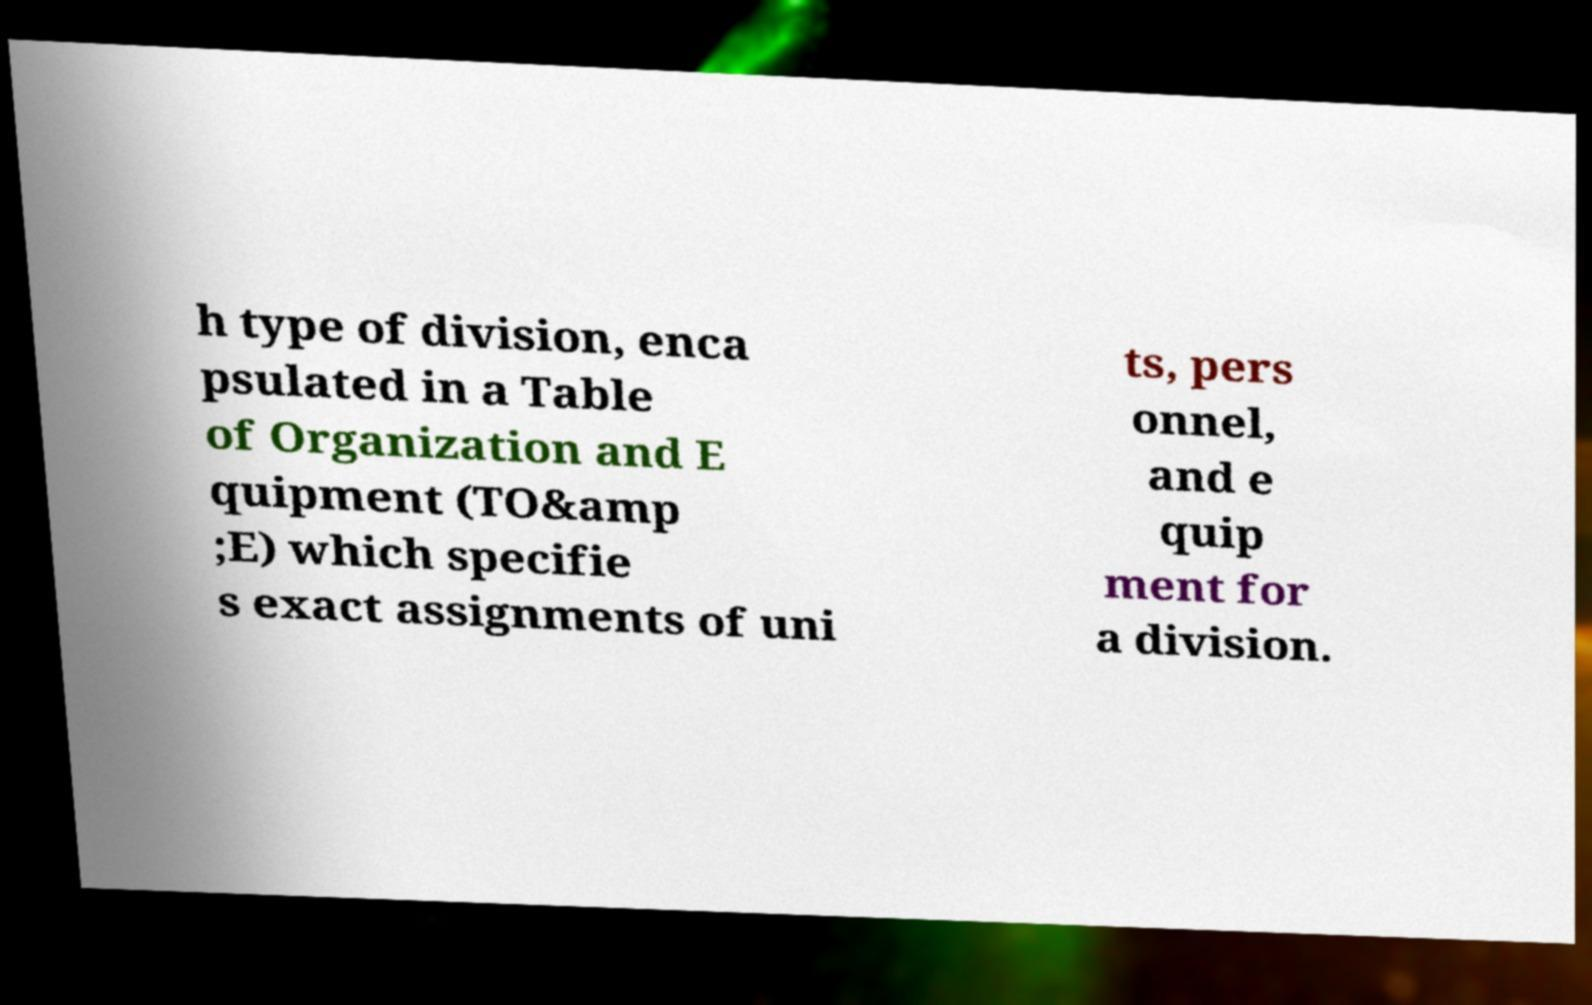Please identify and transcribe the text found in this image. h type of division, enca psulated in a Table of Organization and E quipment (TO&amp ;E) which specifie s exact assignments of uni ts, pers onnel, and e quip ment for a division. 